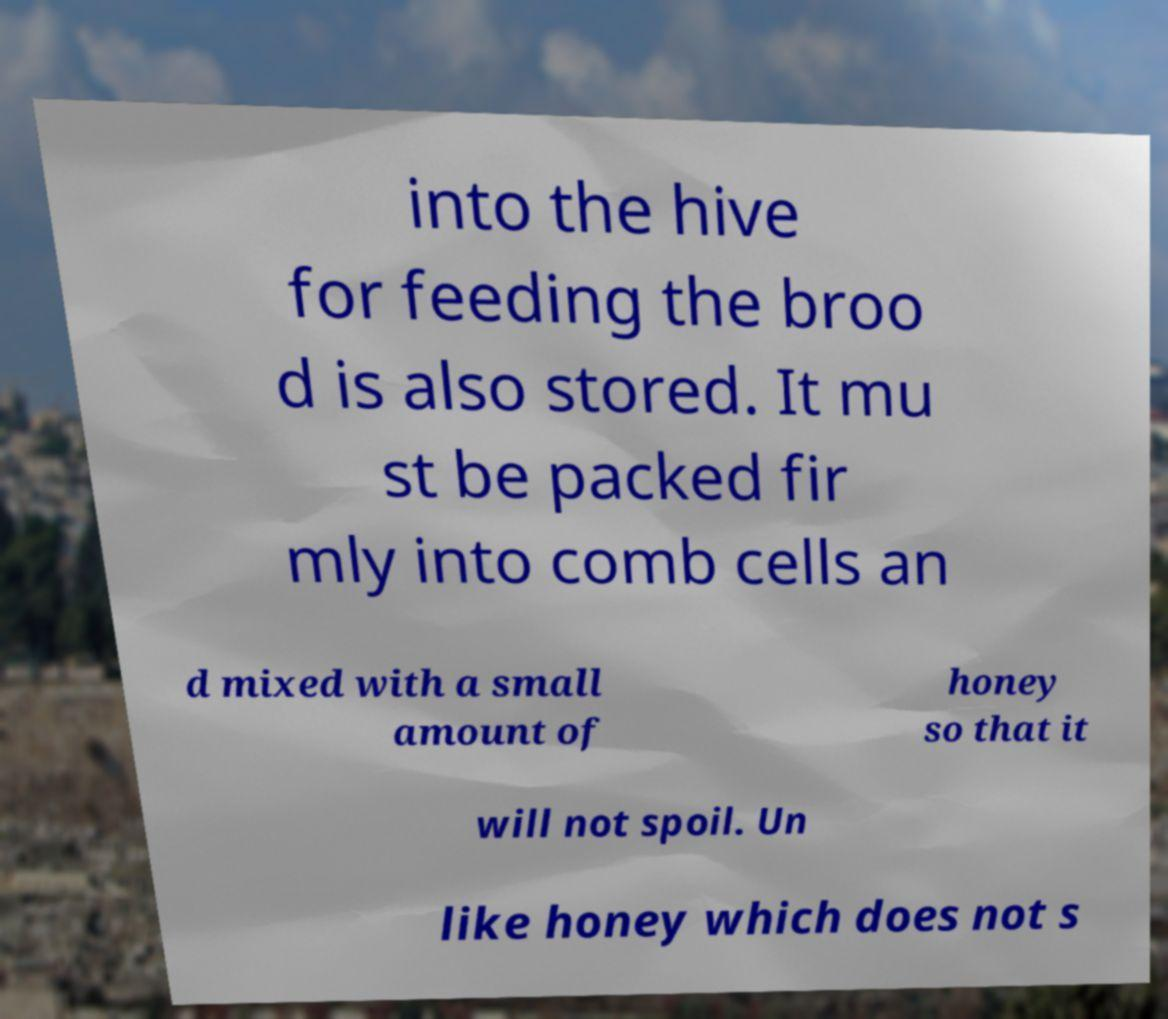Can you accurately transcribe the text from the provided image for me? into the hive for feeding the broo d is also stored. It mu st be packed fir mly into comb cells an d mixed with a small amount of honey so that it will not spoil. Un like honey which does not s 